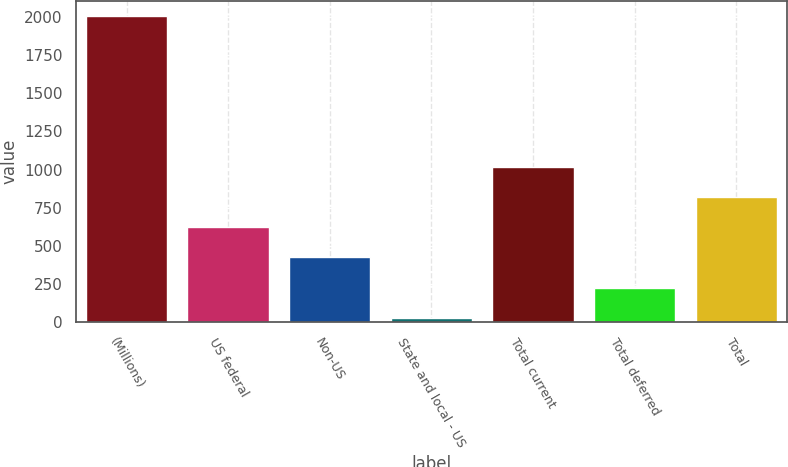Convert chart to OTSL. <chart><loc_0><loc_0><loc_500><loc_500><bar_chart><fcel>(Millions)<fcel>US federal<fcel>Non-US<fcel>State and local - US<fcel>Total current<fcel>Total deferred<fcel>Total<nl><fcel>2006<fcel>622.8<fcel>425.2<fcel>30<fcel>1018<fcel>227.6<fcel>820.4<nl></chart> 